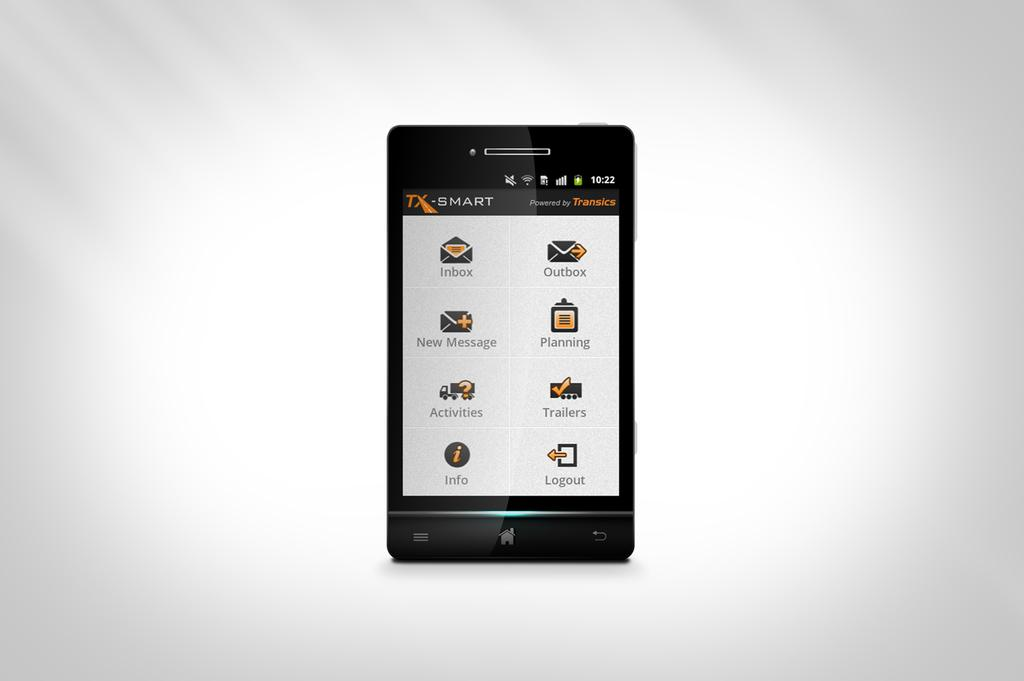<image>
Write a terse but informative summary of the picture. The Smart device has eight icons, including inbox and messaging. 